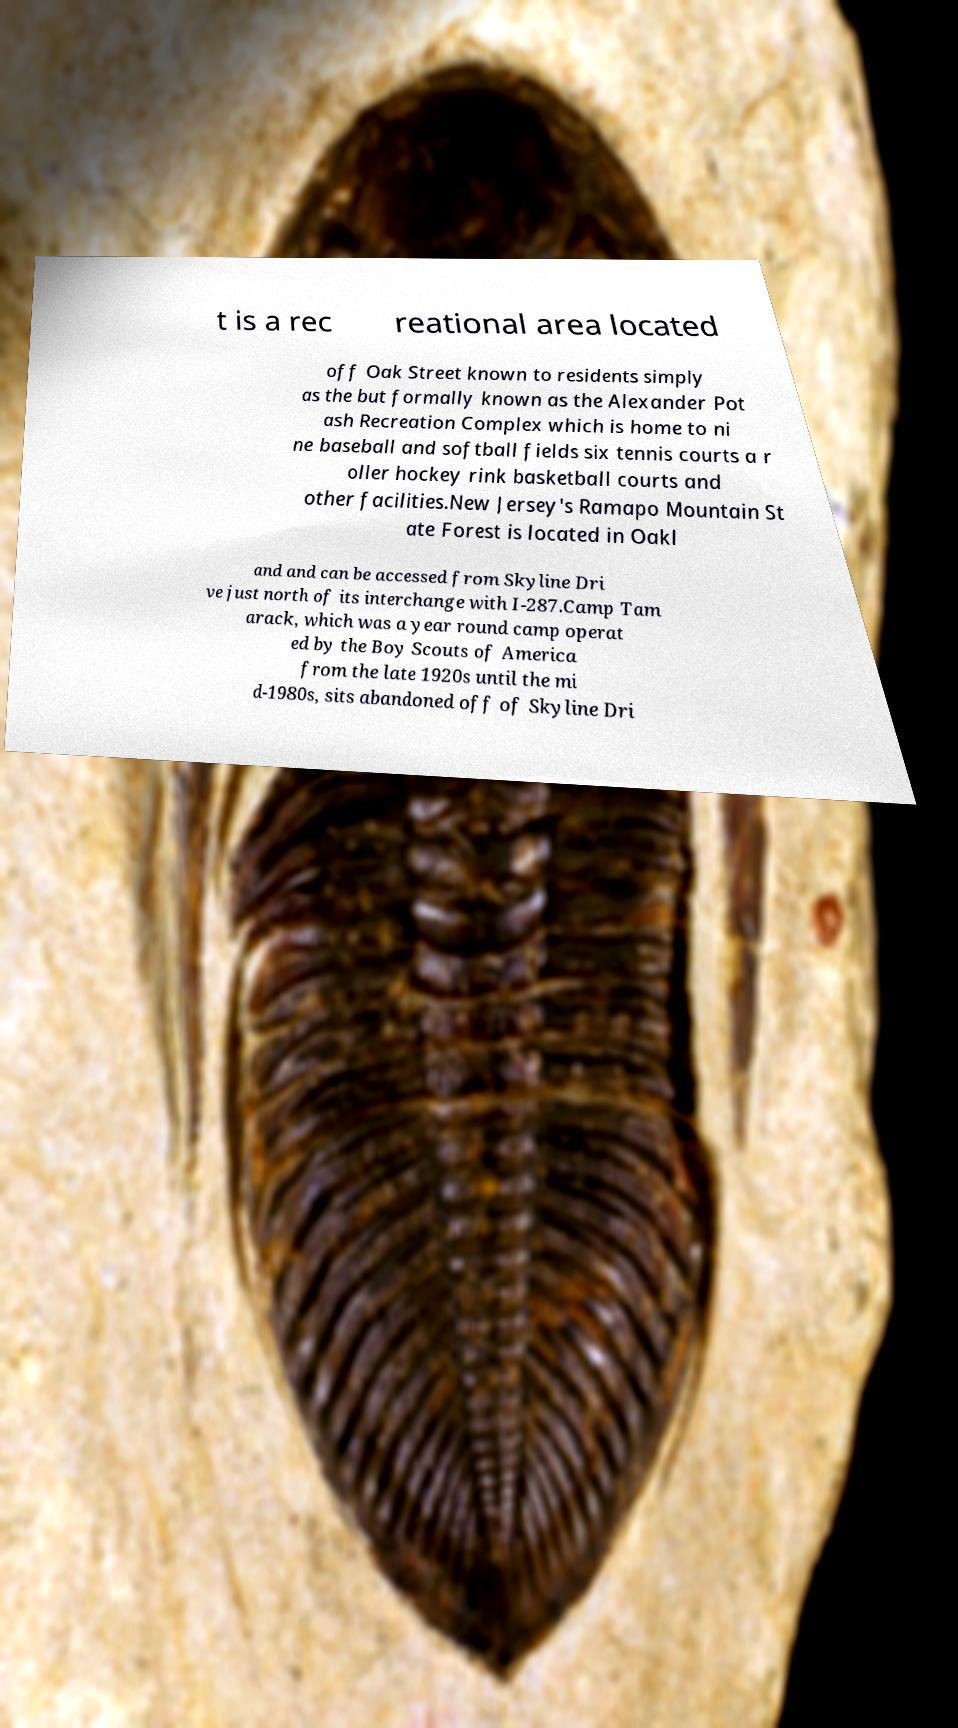I need the written content from this picture converted into text. Can you do that? t is a rec reational area located off Oak Street known to residents simply as the but formally known as the Alexander Pot ash Recreation Complex which is home to ni ne baseball and softball fields six tennis courts a r oller hockey rink basketball courts and other facilities.New Jersey's Ramapo Mountain St ate Forest is located in Oakl and and can be accessed from Skyline Dri ve just north of its interchange with I-287.Camp Tam arack, which was a year round camp operat ed by the Boy Scouts of America from the late 1920s until the mi d-1980s, sits abandoned off of Skyline Dri 